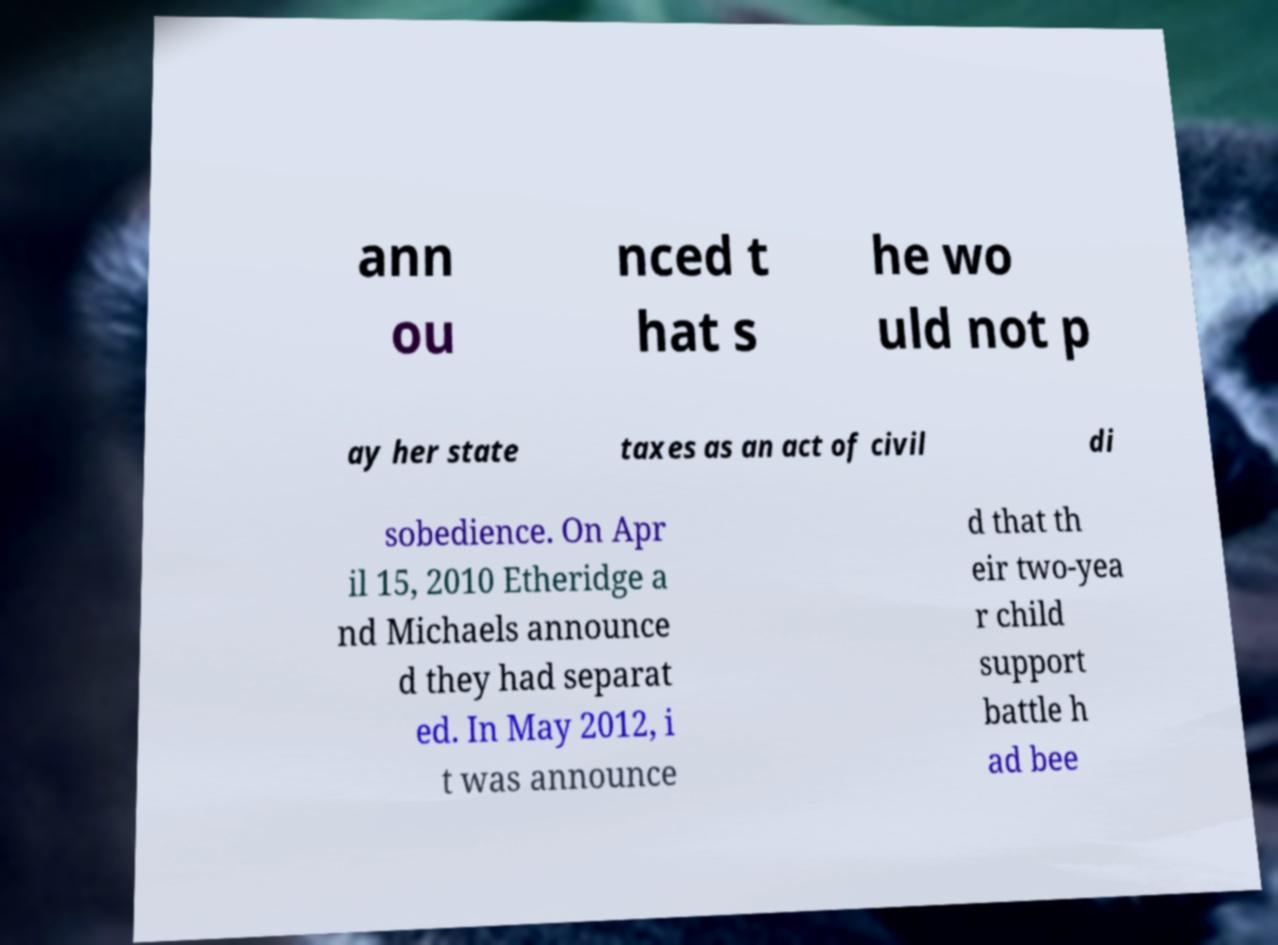What messages or text are displayed in this image? I need them in a readable, typed format. ann ou nced t hat s he wo uld not p ay her state taxes as an act of civil di sobedience. On Apr il 15, 2010 Etheridge a nd Michaels announce d they had separat ed. In May 2012, i t was announce d that th eir two-yea r child support battle h ad bee 